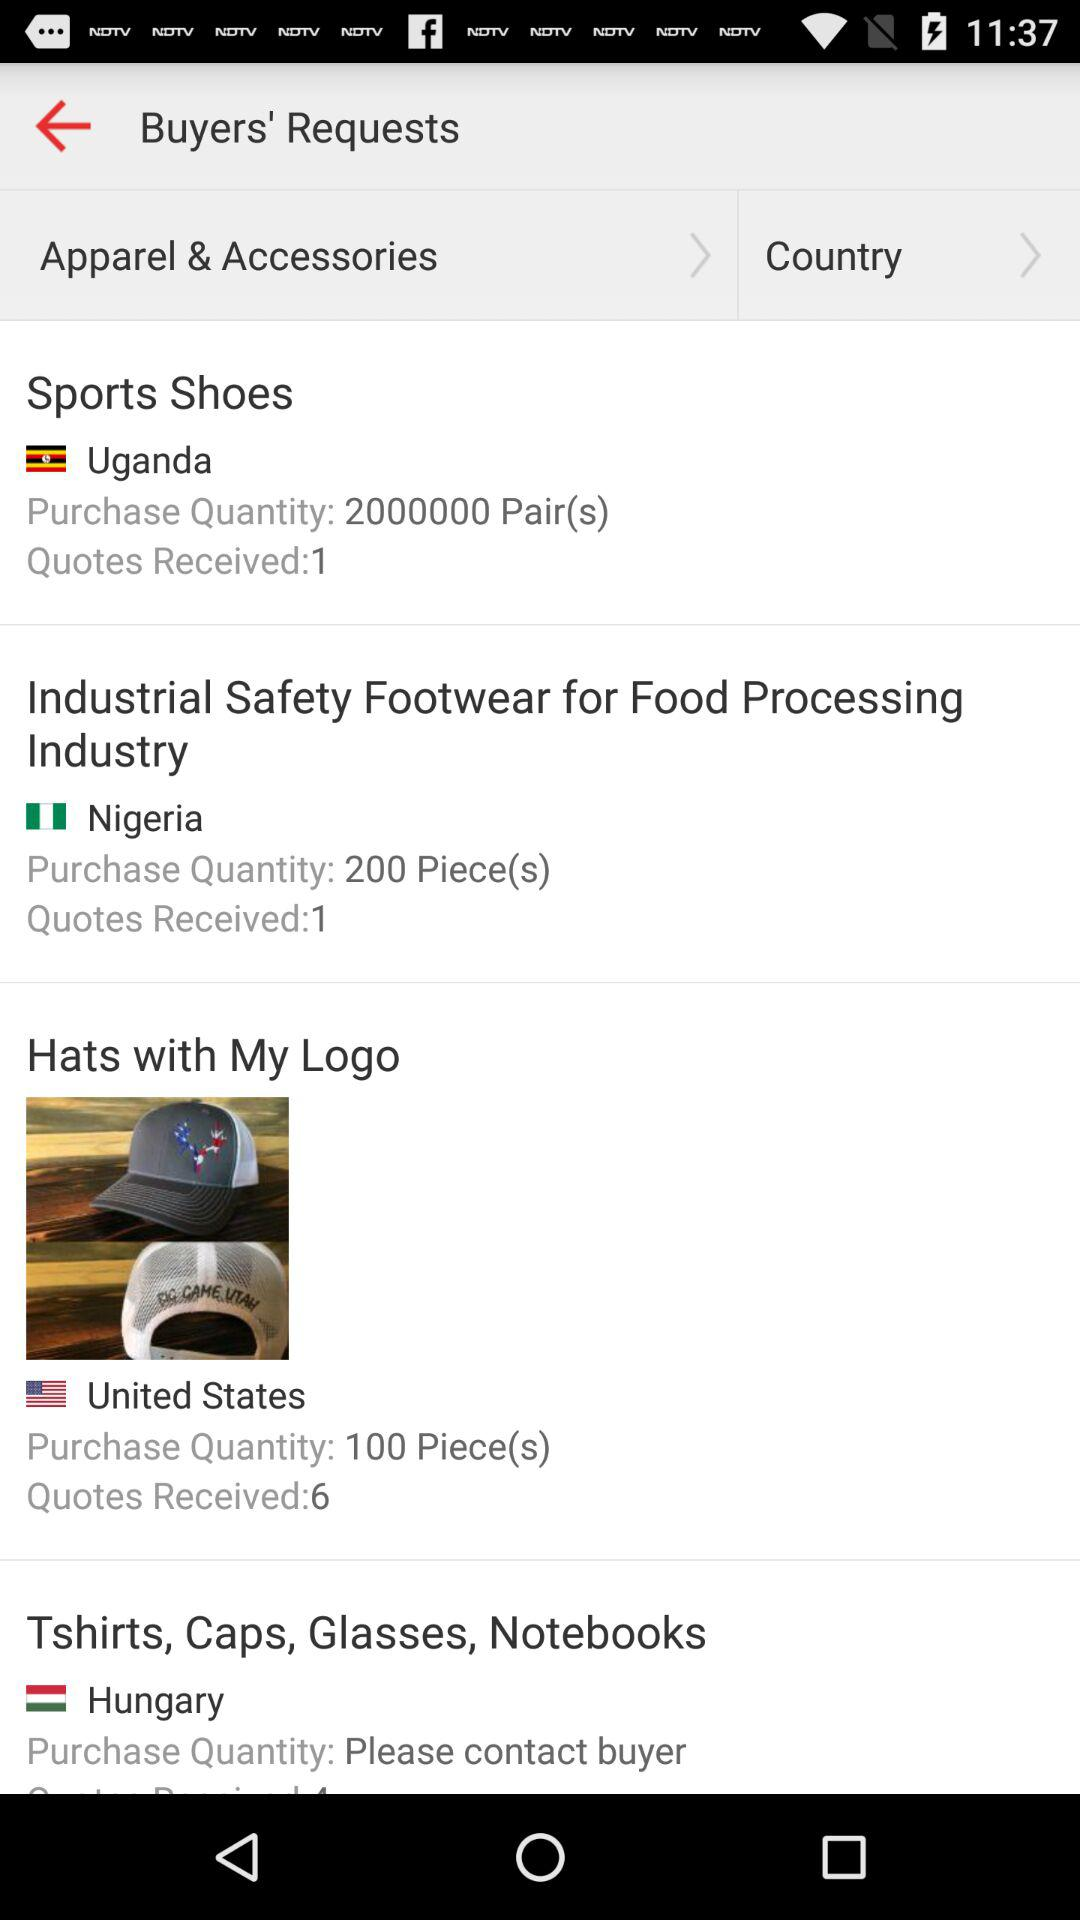How many hats does the United States want to purchase? The United States wants to purchase 100 hats. 